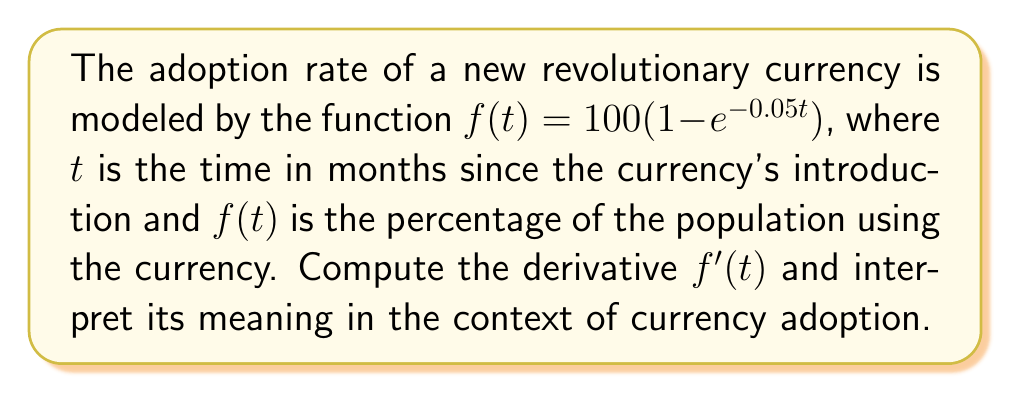Can you solve this math problem? To find the derivative of $f(t)$, we'll use the chain rule:

1) First, let's identify the parts of the function:
   $f(t) = 100(1 - e^{-0.05t})$
   
   Outer function: $100 \times (\text{inner function})$
   Inner function: $1 - e^{-0.05t}$

2) Apply the chain rule:
   $f'(t) = 100 \times \frac{d}{dt}(1 - e^{-0.05t})$

3) Differentiate the inner function:
   $\frac{d}{dt}(1 - e^{-0.05t}) = 0 - \frac{d}{dt}(e^{-0.05t})$

4) Use the chain rule again for $e^{-0.05t}$:
   $\frac{d}{dt}(e^{-0.05t}) = e^{-0.05t} \times \frac{d}{dt}(-0.05t) = -0.05e^{-0.05t}$

5) Combine the results:
   $f'(t) = 100 \times (0 - (-0.05e^{-0.05t})) = 5e^{-0.05t}$

Interpretation: The derivative $f'(t) = 5e^{-0.05t}$ represents the rate of change of the adoption percentage with respect to time. It shows how quickly the new revolutionary currency is being adopted at any given time $t$. The exponential decay in the derivative indicates that the adoption rate is highest at the beginning and gradually slows down over time.
Answer: $f'(t) = 5e^{-0.05t}$ 